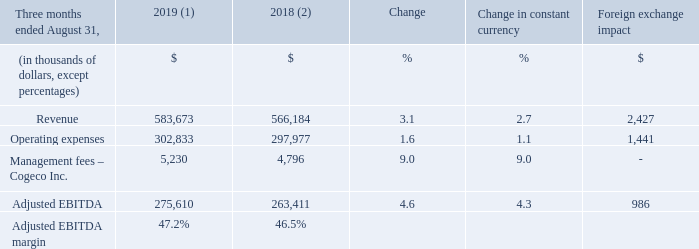OPERATING AND FINANCIAL RESULTS
(1) For the three-month period ended August 31, 2019, the average foreign exchange rate used for translation was 1.3222 USD/CDN.
(2) Fiscal 2018 was restated to comply with IFRS 15 and to reflect a change in accounting policy as well as to reclassify results from Cogeco Peer 1 as discontinued
operations. For further details, please consult the "Accounting policies" and "Discontinued operations" sections.
(3) Fiscal 2019 actuals are translated at the average foreign exchange rate of the comparable period of fiscal 2018 which was 1.3100 USD/CDN.
What was the foreign exchange rate used for the three-month period ended 2019? 1.3222 usd/cdn. What was the foreign exchange rate used For the three-month period ended 2018? 1.3100 usd/cdn. What was the Adjusted EBITDA margin in fourth quarter fiscal year 2019? 47.2%. What was the increase / (decrease) in the revenue from three months ended August 31, 2018 to 2019?
Answer scale should be: thousand. 583,673 - 566,184
Answer: 17489. What was the average operating expenses from three months ended August 31, 2018 to 2019?
Answer scale should be: thousand. (302,833 + 297,977) / 2
Answer: 300405. What was the increase / (decrease) in the Adjusted EBITDA margin from three months ended August 31, 2018 to 2019?
Answer scale should be: percent. 47.2% - 46.5%
Answer: 0.7. 